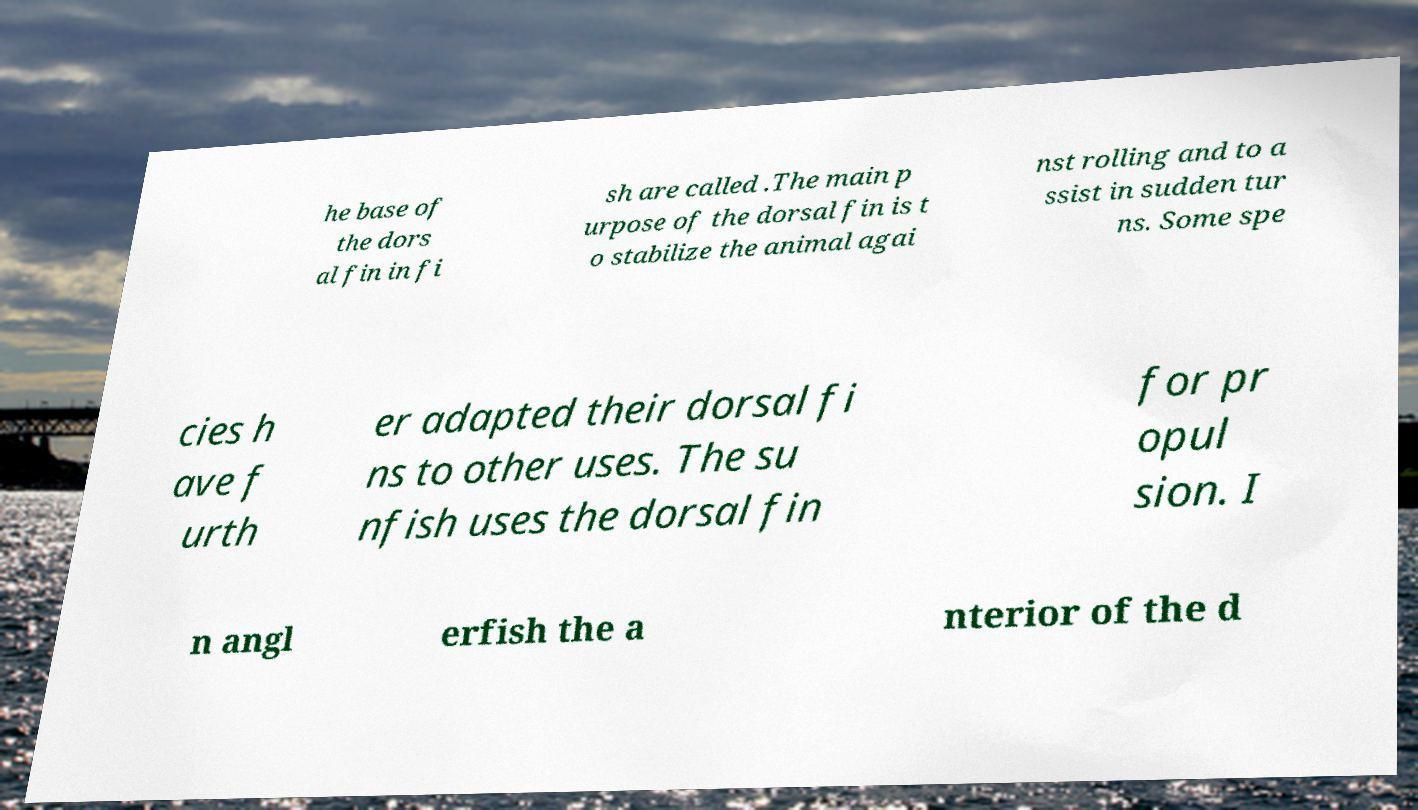Could you assist in decoding the text presented in this image and type it out clearly? he base of the dors al fin in fi sh are called .The main p urpose of the dorsal fin is t o stabilize the animal agai nst rolling and to a ssist in sudden tur ns. Some spe cies h ave f urth er adapted their dorsal fi ns to other uses. The su nfish uses the dorsal fin for pr opul sion. I n angl erfish the a nterior of the d 